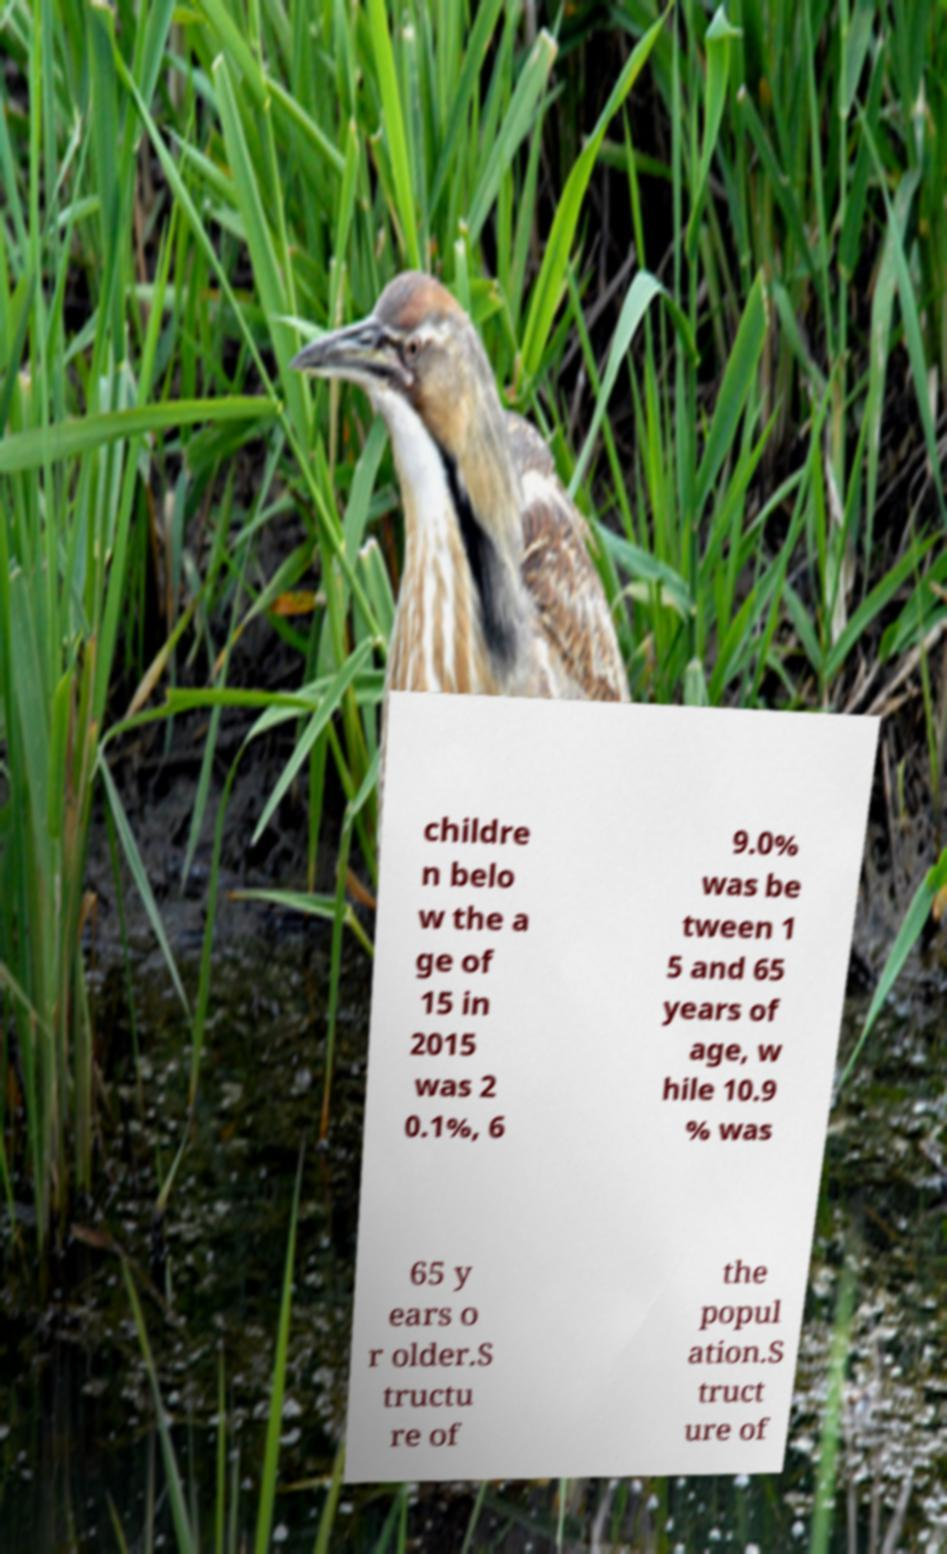Could you extract and type out the text from this image? childre n belo w the a ge of 15 in 2015 was 2 0.1%, 6 9.0% was be tween 1 5 and 65 years of age, w hile 10.9 % was 65 y ears o r older.S tructu re of the popul ation.S truct ure of 